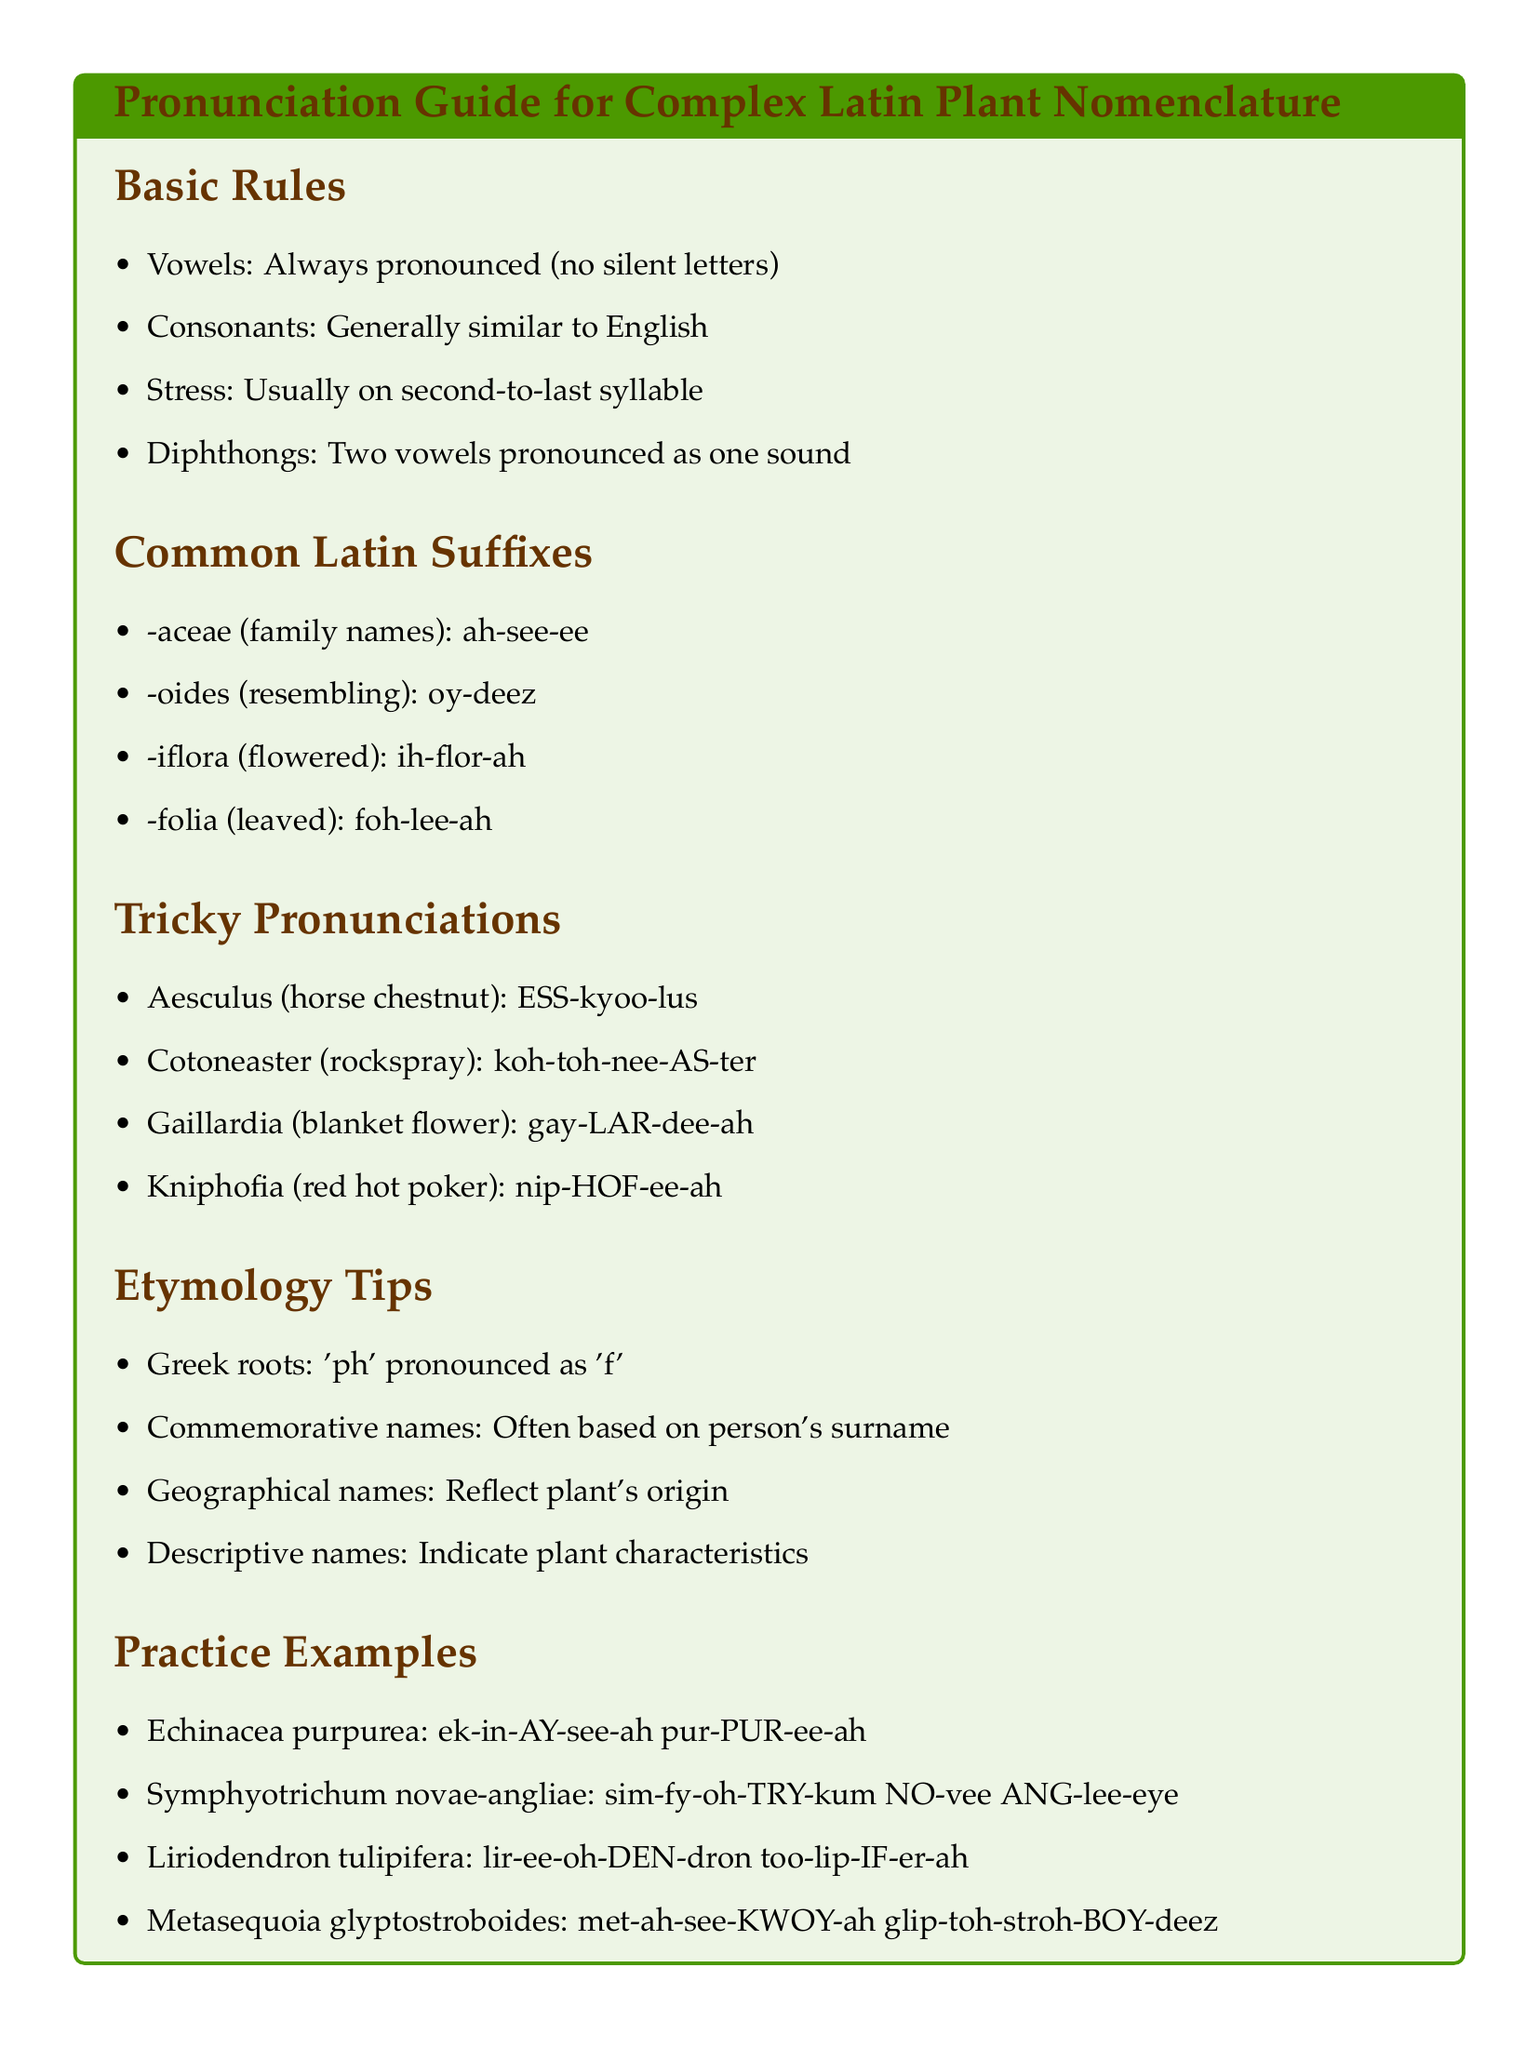What is the pronunciation rule for vowels? Vowels in Latin plant nomenclature are always pronounced, meaning there are no silent letters.
Answer: Always pronounced What is the pronunciation for the suffix "-aceae"? The document provides the pronunciation for Latin suffixes including "-aceae," which is pronounced as "ah-see-ee."
Answer: ah-see-ee What is the tricky pronunciation of "Aesculus"? The tricky pronunciation of "Aesculus," which refers to horse chestnut, is clearly outlined as "ESS-kyoo-lus."
Answer: ESS-kyoo-lus What language influences the pronunciation of "ph"? The document notes that Greek roots influence pronunciation, specifically that "ph" is pronounced as "f."
Answer: Greek Which plant species has the pronunciation "lir-ee-oh-DEN-dron"? The practice examples list "Liriodendron tulipifera" with its pronunciation as "lir-ee-oh-DEN-dron."
Answer: Liriodendron tulipifera What is indicated by descriptive names in plant nomenclature? The document explains that descriptive names refer to characteristics of the plant itself.
Answer: Characteristics Where is the stress usually placed in Latin plant names? According to the basic rules, the stress is usually on the second-to-last syllable in Latin plant names.
Answer: Second-to-last syllable What suffix indicates a resemblance in Latin plant terminology? The suffix "-oides" indicates resemblance, and it is pronounced as "oy-deez."
Answer: -oides How many examples of tricky pronunciations are provided? The document includes four examples of tricky pronunciations within the "Tricky Pronunciations" section.
Answer: Four 